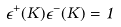Convert formula to latex. <formula><loc_0><loc_0><loc_500><loc_500>\epsilon ^ { + } ( K ) \epsilon ^ { - } ( K ) = 1</formula> 